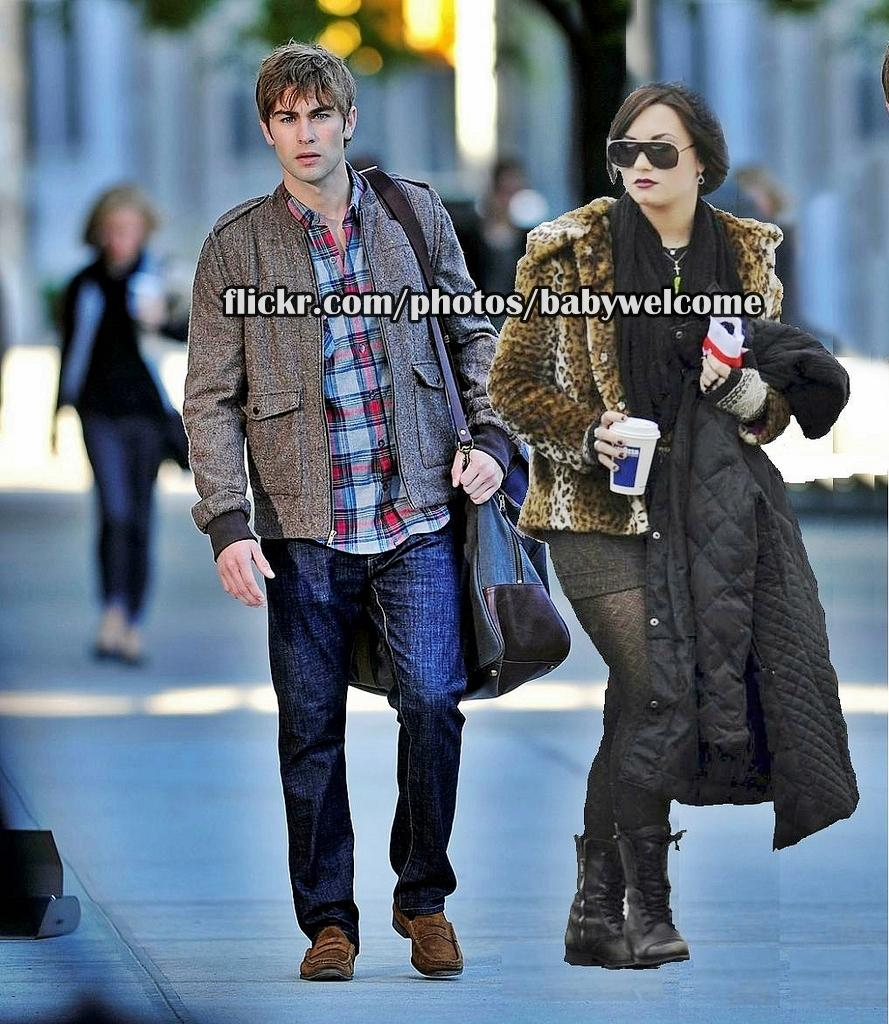How many people are in the image? There are two people in the image. What are the two people doing in the image? The two people are walking together. Can you describe the background of the image? The background of the second picture is blurred. What type of mass can be seen in the image? There is no mass present in the image; it features two people walking together. What color is the bag carried by the person in the image? There is no bag present in the image; it only shows two people walking together. 